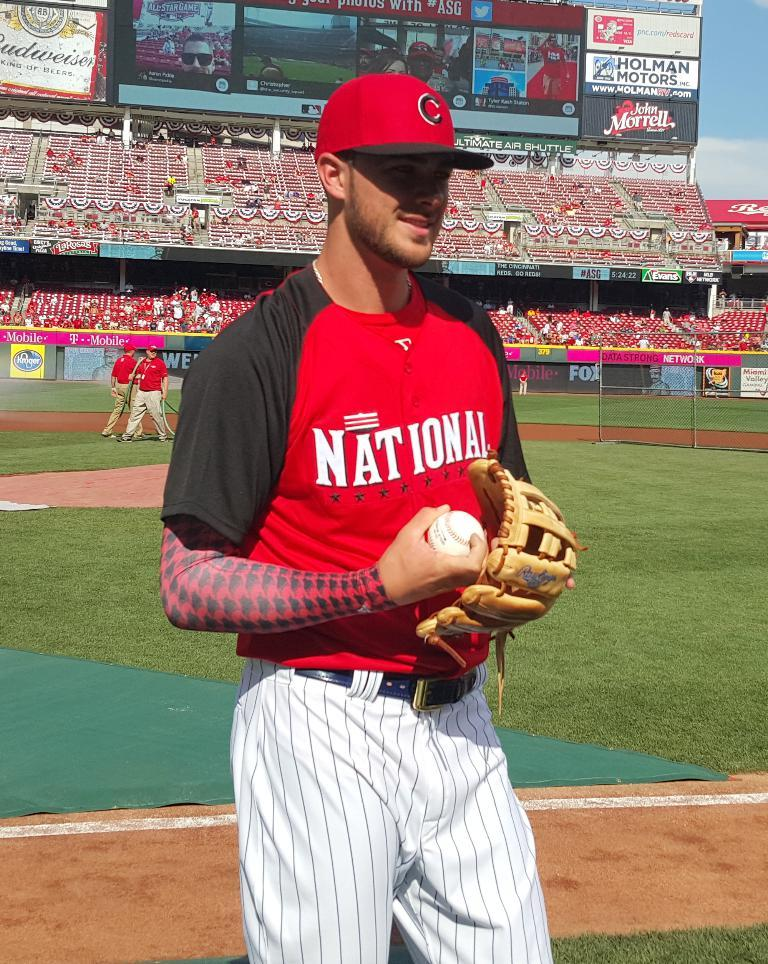<image>
Write a terse but informative summary of the picture. A baseball player stands holding a ball with his glove looking at something while a Budweiser can be seen on the jumbo tron. 